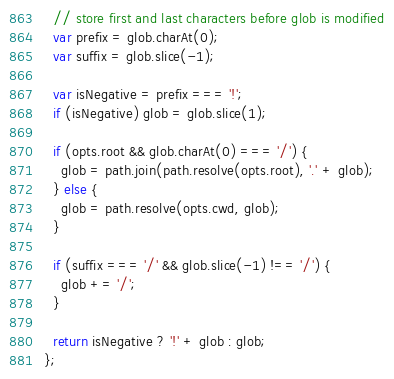<code> <loc_0><loc_0><loc_500><loc_500><_JavaScript_>
  // store first and last characters before glob is modified
  var prefix = glob.charAt(0);
  var suffix = glob.slice(-1);

  var isNegative = prefix === '!';
  if (isNegative) glob = glob.slice(1);

  if (opts.root && glob.charAt(0) === '/') {
    glob = path.join(path.resolve(opts.root), '.' + glob);
  } else {
    glob = path.resolve(opts.cwd, glob);
  }

  if (suffix === '/' && glob.slice(-1) !== '/') {
    glob += '/';
  }

  return isNegative ? '!' + glob : glob;
};
</code> 